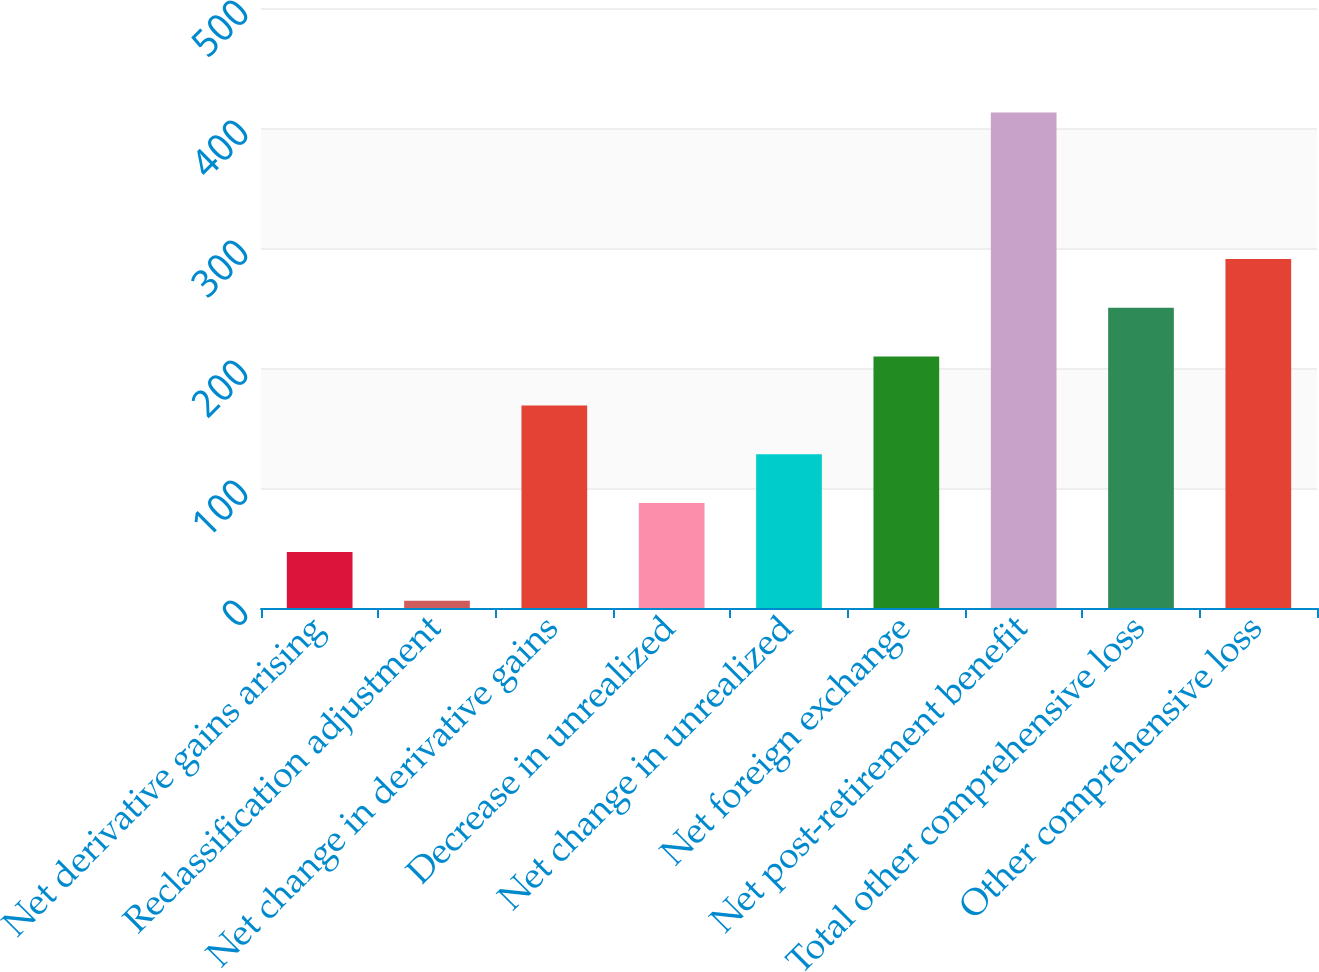<chart> <loc_0><loc_0><loc_500><loc_500><bar_chart><fcel>Net derivative gains arising<fcel>Reclassification adjustment<fcel>Net change in derivative gains<fcel>Decrease in unrealized<fcel>Net change in unrealized<fcel>Net foreign exchange<fcel>Net post-retirement benefit<fcel>Total other comprehensive loss<fcel>Other comprehensive loss<nl><fcel>46.7<fcel>6<fcel>168.8<fcel>87.4<fcel>128.1<fcel>209.5<fcel>413<fcel>250.2<fcel>290.9<nl></chart> 